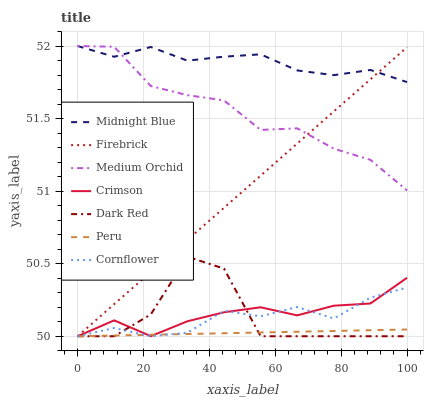Does Peru have the minimum area under the curve?
Answer yes or no. Yes. Does Midnight Blue have the maximum area under the curve?
Answer yes or no. Yes. Does Dark Red have the minimum area under the curve?
Answer yes or no. No. Does Dark Red have the maximum area under the curve?
Answer yes or no. No. Is Firebrick the smoothest?
Answer yes or no. Yes. Is Dark Red the roughest?
Answer yes or no. Yes. Is Midnight Blue the smoothest?
Answer yes or no. No. Is Midnight Blue the roughest?
Answer yes or no. No. Does Cornflower have the lowest value?
Answer yes or no. Yes. Does Midnight Blue have the lowest value?
Answer yes or no. No. Does Medium Orchid have the highest value?
Answer yes or no. Yes. Does Dark Red have the highest value?
Answer yes or no. No. Is Peru less than Medium Orchid?
Answer yes or no. Yes. Is Midnight Blue greater than Crimson?
Answer yes or no. Yes. Does Firebrick intersect Cornflower?
Answer yes or no. Yes. Is Firebrick less than Cornflower?
Answer yes or no. No. Is Firebrick greater than Cornflower?
Answer yes or no. No. Does Peru intersect Medium Orchid?
Answer yes or no. No. 